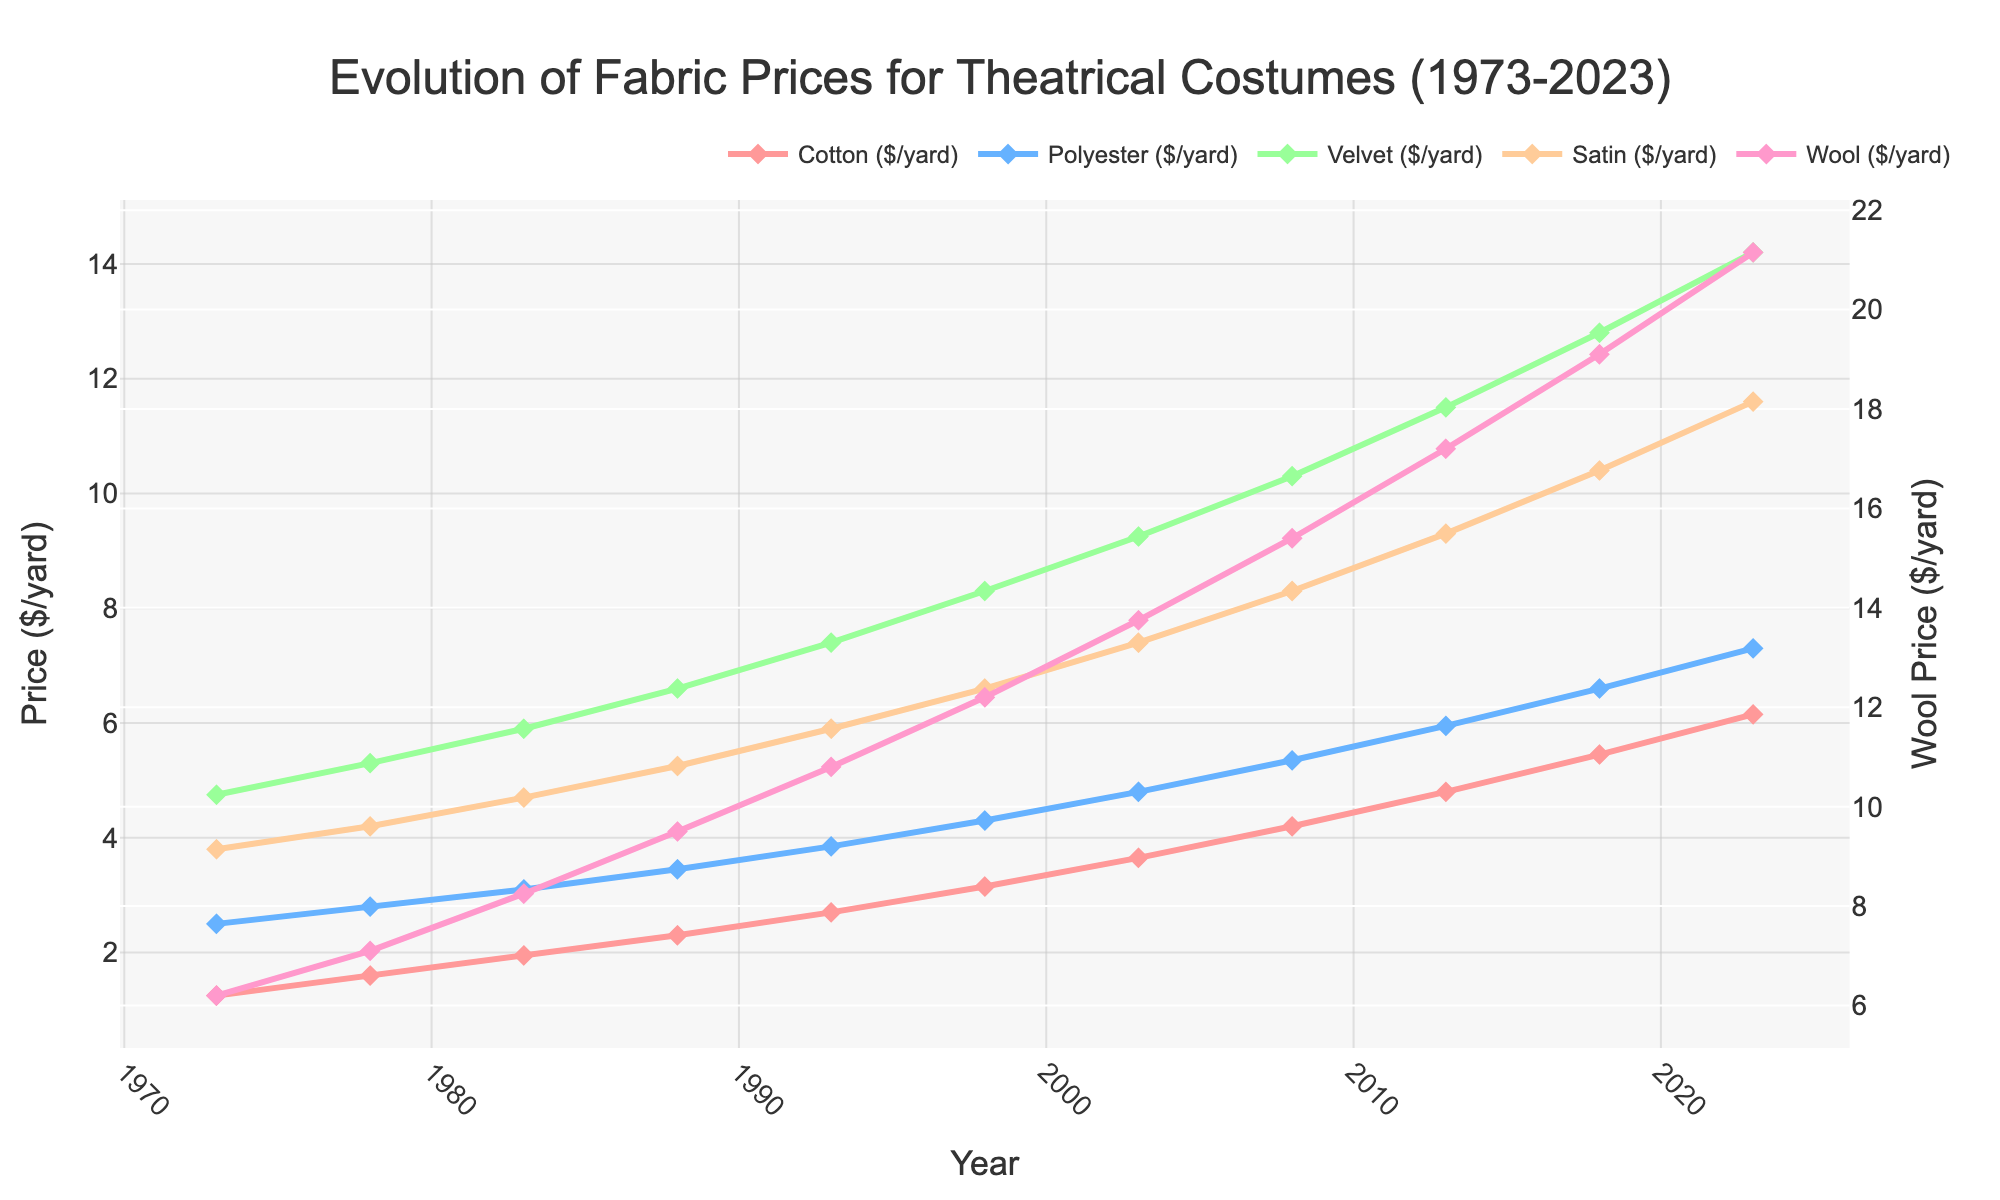What's the general trend in fabric prices for theatrical costumes from 1973 to 2023? Each fabric type (Cotton, Polyester, Velvet, Satin, and Wool) has a line that shows an increasing trend over the span of 50 years, indicating that prices for all fabrics have risen consistently.
Answer: Increasing Between Cotton and Velvet, which fabric had a higher price increase from 1973 to 2023? Cotton increased from $1.25 to $6.15 per yard, resulting in an increase of $4.90. Velvet increased from $4.75 to $14.20 per yard, resulting in an increase of $9.45. Thus, Velvet had a higher price increase.
Answer: Velvet What is the difference in price between Satin and Wool in 2023? In 2023, the price of Satin is $11.60 per yard, and the price of Wool is $21.15 per yard. The difference is $21.15 - $11.60 = $9.55.
Answer: $9.55 How does the price of Polyester in 1998 compare to the price of Cotton in the same year? In 1998, the price of Polyester is $4.30 per yard, and the price of Cotton is $3.15 per yard. Polyester is more expensive than Cotton in that year.
Answer: Polyester is more expensive Which fabric had the most significant price increase in the period from 2018 to 2023? Computing the differences for each fabric between 2018 and 2023, we get:
- Cotton: $6.15 - $5.45 = $0.70
- Polyester: $7.30 - $6.60 = $0.70
- Velvet: $14.20 - $12.80 = $1.40
- Satin: $11.60 - $10.40 = $1.20
- Wool: $21.15 - $19.10 = $2.05
Wool had the most significant price increase.
Answer: Wool What is the average price of Velvet over the entire period from 1973 to 2023? Sum all Velvet prices: $4.75 + $5.30 + $5.90 + $6.60 + $7.40 + $8.30 + $9.25 + $10.30 + $11.50 + $12.80 + $14.20 = $96.30. There are 11 data points, so the average is $96.30 / 11 ≈ $8.75.
Answer: $8.75 What year did Cotton prices surpass $4 per yard? By examining the plot or data, we can see that Cotton prices reached $4.20 per yard in 2008, which is the first year above $4.
Answer: 2008 What fabric was the least expensive in 2013? By looking at the 2013 data, we can compare:
- Cotton: $4.80
- Polyester: $5.95
- Velvet: $11.50
- Satin: $9.30
- Wool: $17.20
Cotton was the least expensive in 2013.
Answer: Cotton At what year did Satin first exceed $5 per yard? According to the data, Satin first exceeded $5 per yard in 1988 when it reached $5.25.
Answer: 1988 Which fabric showed a relatively steady price over the entire period? By observing the line trends, Polyester shows the steadiest price increase with minimal fluctuation compared to the other fabrics.
Answer: Polyester 